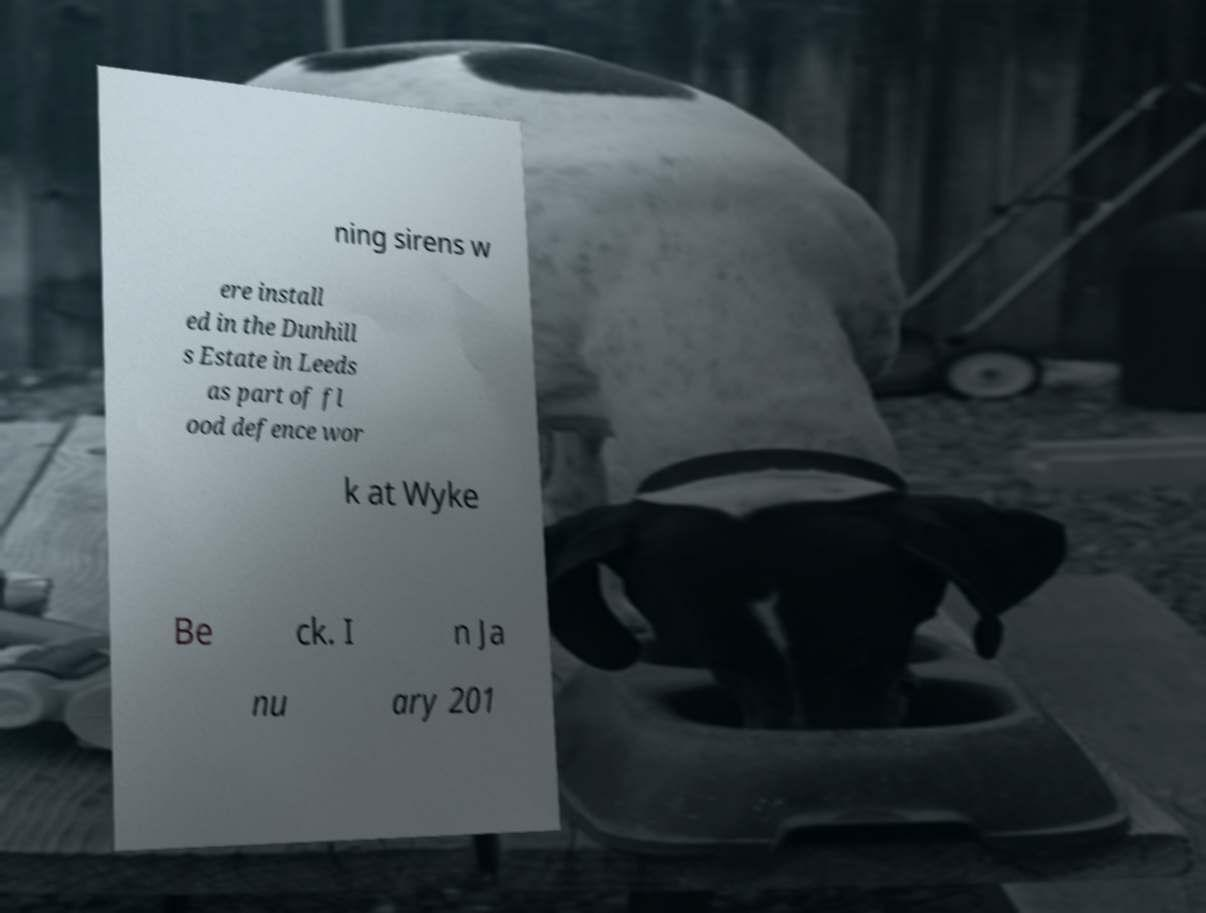Please identify and transcribe the text found in this image. ning sirens w ere install ed in the Dunhill s Estate in Leeds as part of fl ood defence wor k at Wyke Be ck. I n Ja nu ary 201 